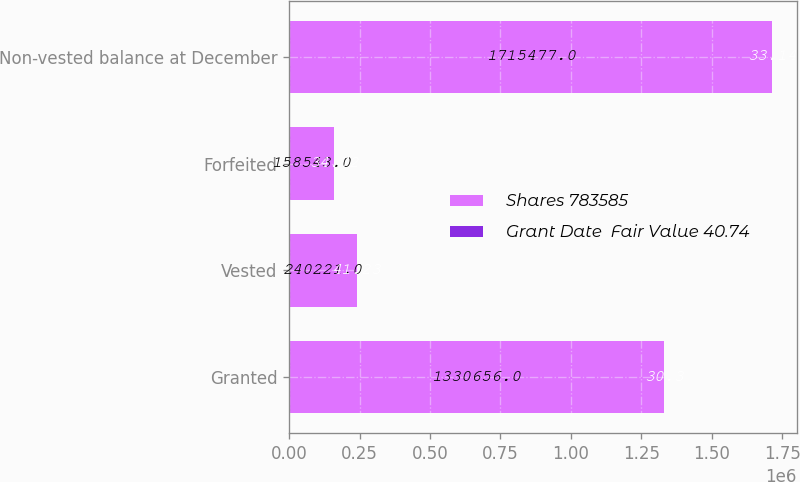Convert chart. <chart><loc_0><loc_0><loc_500><loc_500><stacked_bar_chart><ecel><fcel>Granted<fcel>Vested<fcel>Forfeited<fcel>Non-vested balance at December<nl><fcel>Shares 783585<fcel>1.33066e+06<fcel>240221<fcel>158543<fcel>1.71548e+06<nl><fcel>Grant Date  Fair Value 40.74<fcel>30.3<fcel>41.23<fcel>34.72<fcel>33.14<nl></chart> 